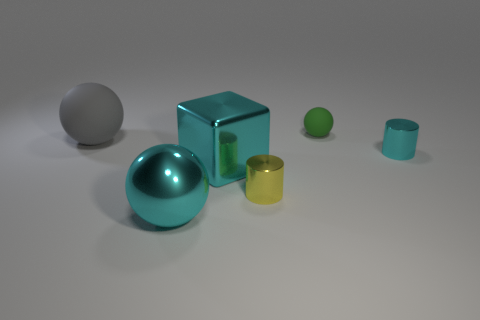Add 2 big cyan things. How many objects exist? 8 Subtract all blocks. How many objects are left? 5 Add 5 big purple rubber blocks. How many big purple rubber blocks exist? 5 Subtract 0 brown cylinders. How many objects are left? 6 Subtract all yellow shiny cylinders. Subtract all large gray rubber spheres. How many objects are left? 4 Add 3 large cyan spheres. How many large cyan spheres are left? 4 